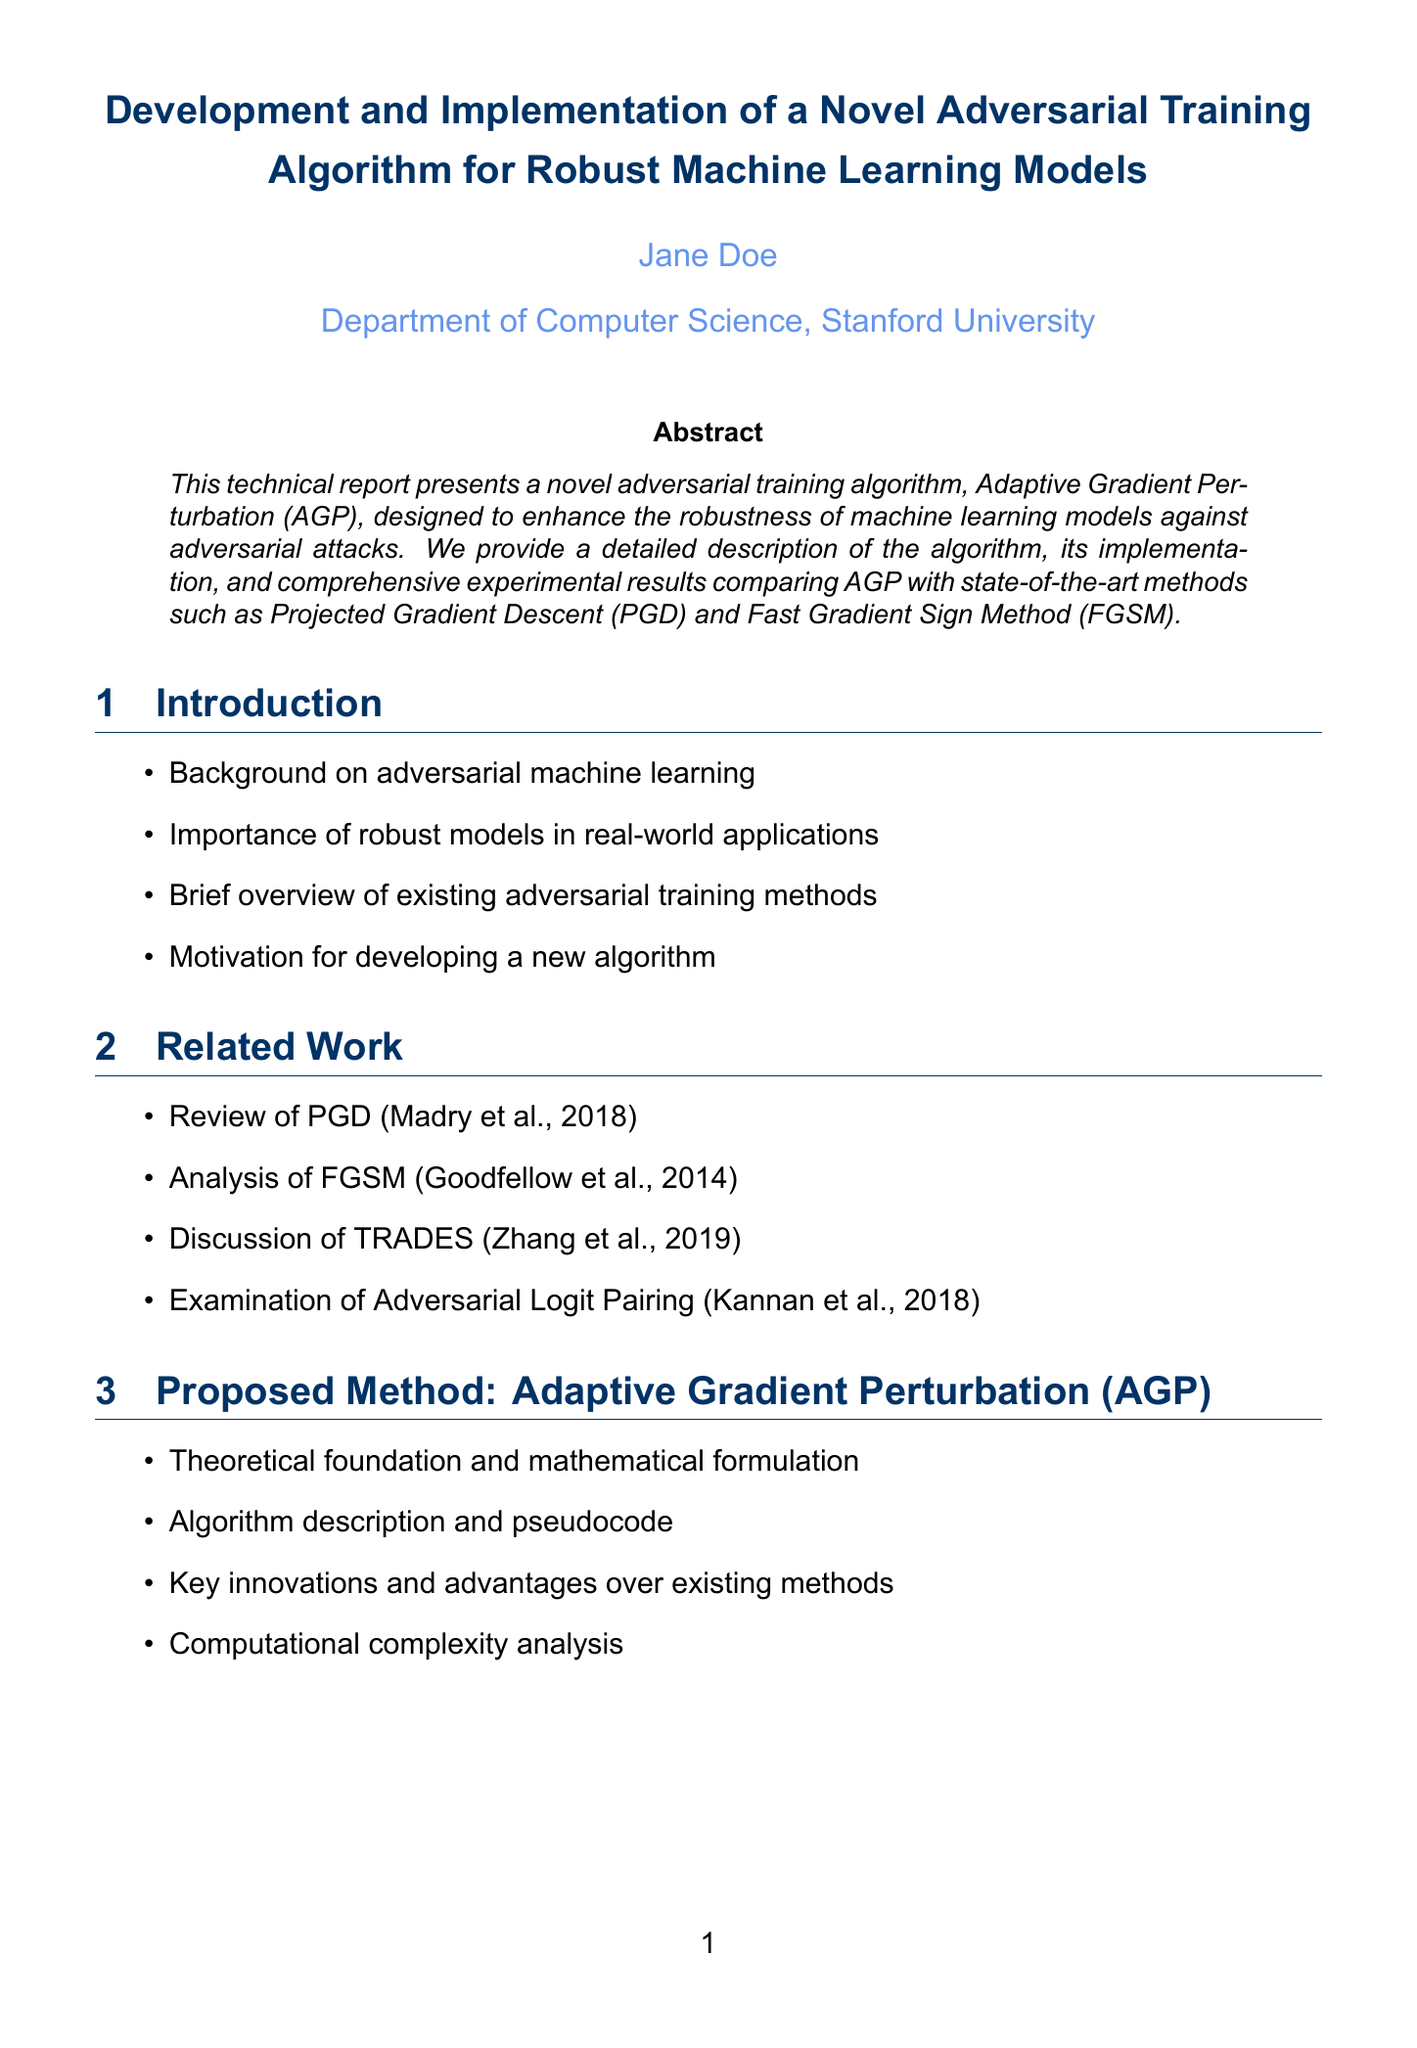what is the title of the report? The title is presented at the beginning of the document.
Answer: Development and Implementation of a Novel Adversarial Training Algorithm for Robust Machine Learning Models who is the author of the report? The author's name is mentioned under the title.
Answer: Jane Doe what is the name of the proposed method? The proposed method is highlighted in the report's sections.
Answer: Adaptive Gradient Perturbation (AGP) which software framework was used for implementation? The software framework is listed in the implementation details section.
Answer: PyTorch 1.9.0 what are the evaluation metrics used in the experimental setup? The evaluation metrics are outlined in the experimental setup section.
Answer: Accuracy, Robustness, and Efficiency how many datasets were used for experiments? The number of datasets used is stated in the experimental setup section.
Answer: Three mention one key innovation of AGP over existing methods. Key innovations are discussed in the proposed method section.
Answer: Not specified (assumes user familiar with AGP) what was the hardware used for implementation? The hardware specifications are mentioned in the implementation details.
Answer: NVIDIA Tesla V100 GPUs in which year was the referenced work on PGD published? The year of publication is noted in the related work section.
Answer: 2018 